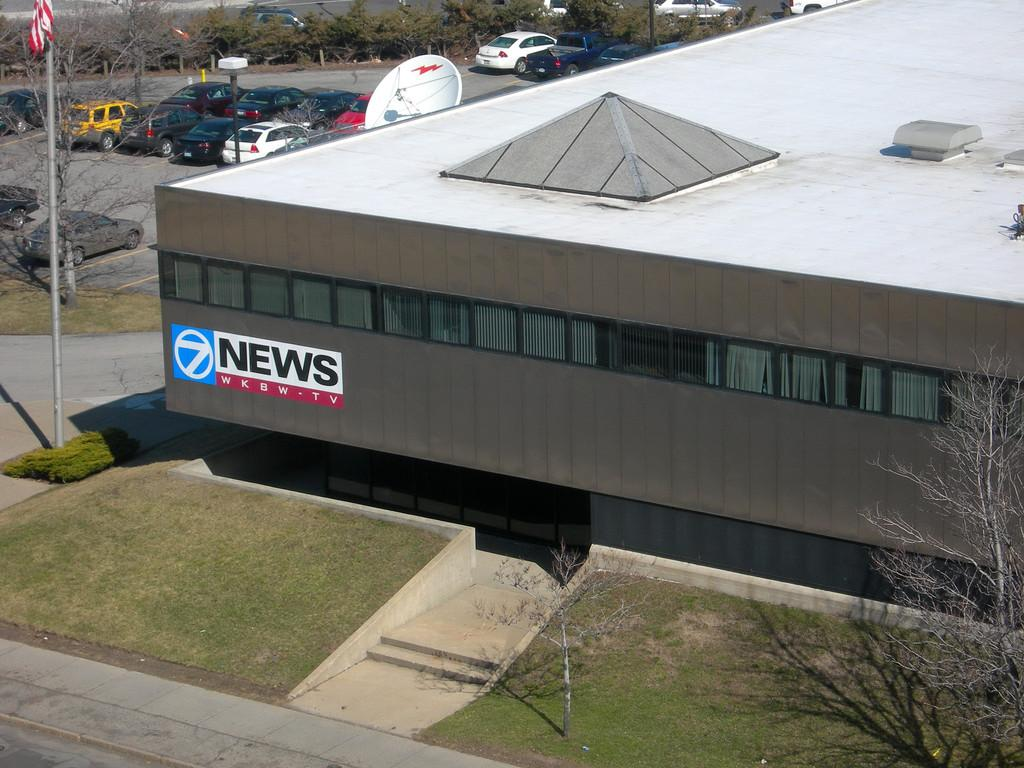What can be seen flying or waving in the image? There is a flag in the image. What is the flag attached to? The flag is attached to a pole in the image. What type of structure is visible in the image? There is a building in the image. What type of natural environment is present in the image? There are trees and grass in the image. What type of man-made objects can be seen in the image? There are vehicles in the image. What type of dish is present in the image? There is a dish in the image. Can you see a farmer working in the field in the image? There is no farmer or field present in the image. What type of thrill can be experienced by the people in the image? The image does not depict any specific activity or experience that would suggest a thrill. 